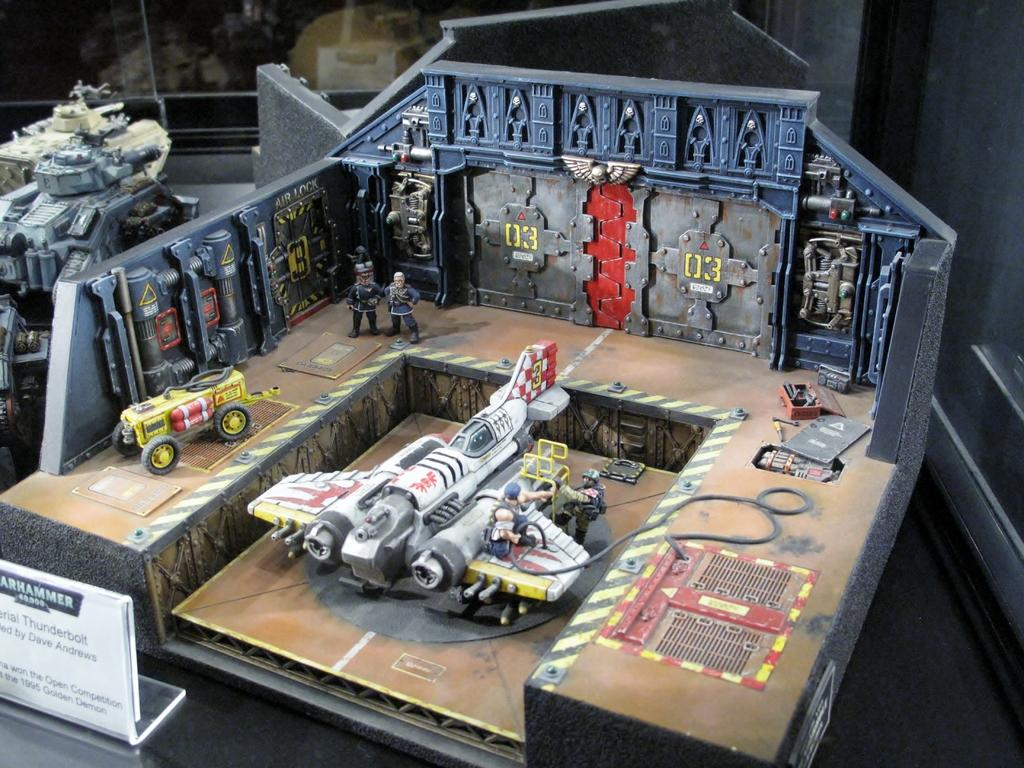What type of objects can be seen in the image? There are toys in the image. What other object is present in the image besides the toys? There is a board in the image. What type of headwear is the toy wearing in the image? There is no indication of any headwear on the toys in the image. 